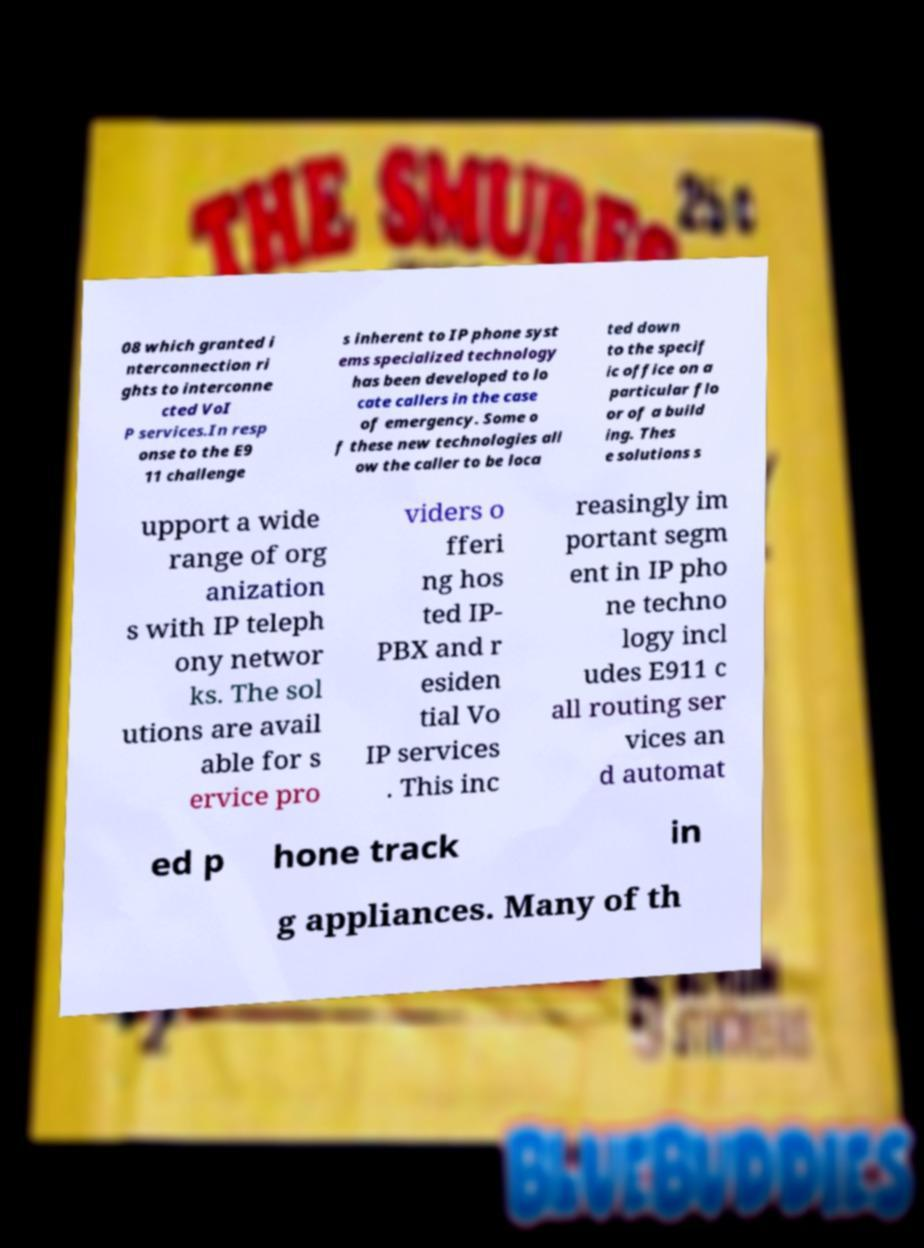Can you read and provide the text displayed in the image?This photo seems to have some interesting text. Can you extract and type it out for me? 08 which granted i nterconnection ri ghts to interconne cted VoI P services.In resp onse to the E9 11 challenge s inherent to IP phone syst ems specialized technology has been developed to lo cate callers in the case of emergency. Some o f these new technologies all ow the caller to be loca ted down to the specif ic office on a particular flo or of a build ing. Thes e solutions s upport a wide range of org anization s with IP teleph ony networ ks. The sol utions are avail able for s ervice pro viders o fferi ng hos ted IP- PBX and r esiden tial Vo IP services . This inc reasingly im portant segm ent in IP pho ne techno logy incl udes E911 c all routing ser vices an d automat ed p hone track in g appliances. Many of th 